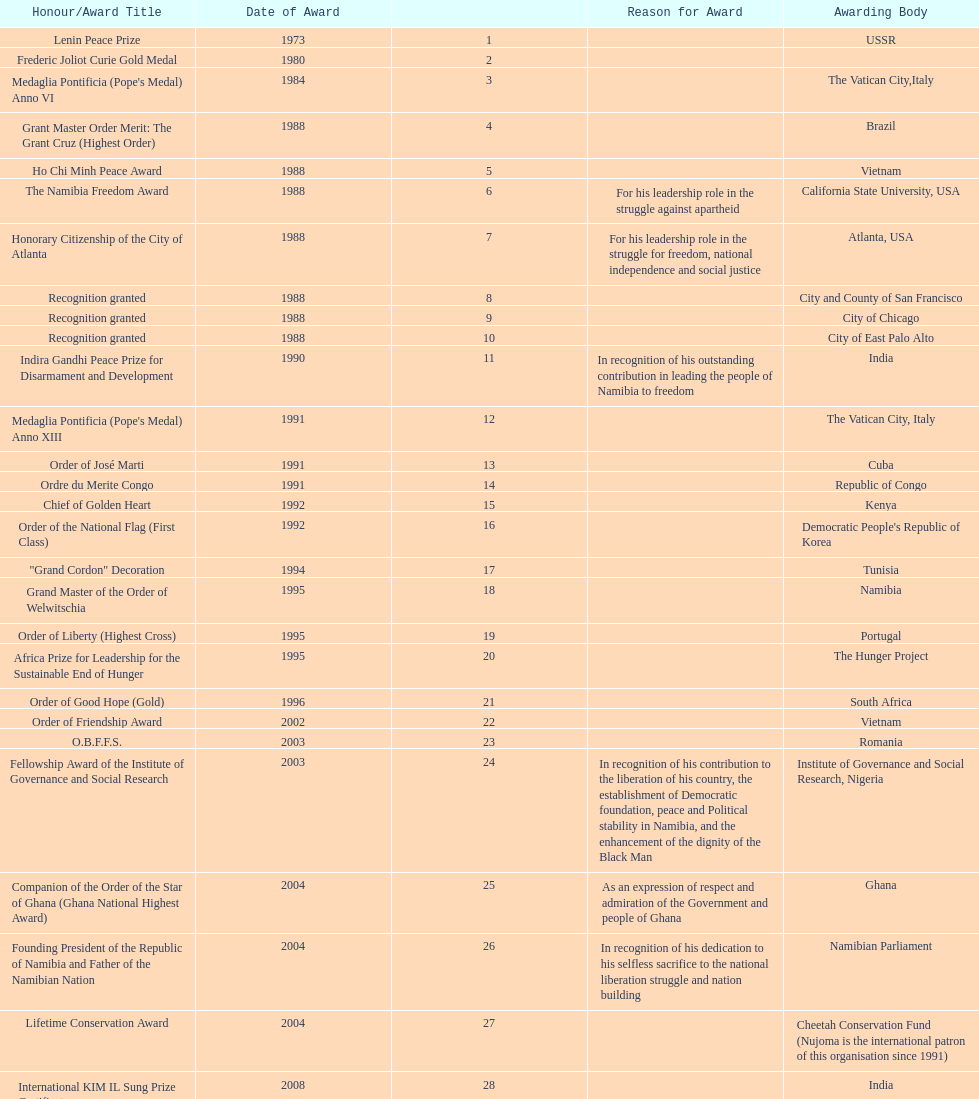What were the total number of honors/award titles listed according to this chart? 29. Help me parse the entirety of this table. {'header': ['Honour/Award Title', 'Date of Award', '', 'Reason for Award', 'Awarding Body'], 'rows': [['Lenin Peace Prize', '1973', '1', '', 'USSR'], ['Frederic Joliot Curie Gold Medal', '1980', '2', '', ''], ["Medaglia Pontificia (Pope's Medal) Anno VI", '1984', '3', '', 'The Vatican City,Italy'], ['Grant Master Order Merit: The Grant Cruz (Highest Order)', '1988', '4', '', 'Brazil'], ['Ho Chi Minh Peace Award', '1988', '5', '', 'Vietnam'], ['The Namibia Freedom Award', '1988', '6', 'For his leadership role in the struggle against apartheid', 'California State University, USA'], ['Honorary Citizenship of the City of Atlanta', '1988', '7', 'For his leadership role in the struggle for freedom, national independence and social justice', 'Atlanta, USA'], ['Recognition granted', '1988', '8', '', 'City and County of San Francisco'], ['Recognition granted', '1988', '9', '', 'City of Chicago'], ['Recognition granted', '1988', '10', '', 'City of East Palo Alto'], ['Indira Gandhi Peace Prize for Disarmament and Development', '1990', '11', 'In recognition of his outstanding contribution in leading the people of Namibia to freedom', 'India'], ["Medaglia Pontificia (Pope's Medal) Anno XIII", '1991', '12', '', 'The Vatican City, Italy'], ['Order of José Marti', '1991', '13', '', 'Cuba'], ['Ordre du Merite Congo', '1991', '14', '', 'Republic of Congo'], ['Chief of Golden Heart', '1992', '15', '', 'Kenya'], ['Order of the National Flag (First Class)', '1992', '16', '', "Democratic People's Republic of Korea"], ['"Grand Cordon" Decoration', '1994', '17', '', 'Tunisia'], ['Grand Master of the Order of Welwitschia', '1995', '18', '', 'Namibia'], ['Order of Liberty (Highest Cross)', '1995', '19', '', 'Portugal'], ['Africa Prize for Leadership for the Sustainable End of Hunger', '1995', '20', '', 'The Hunger Project'], ['Order of Good Hope (Gold)', '1996', '21', '', 'South Africa'], ['Order of Friendship Award', '2002', '22', '', 'Vietnam'], ['O.B.F.F.S.', '2003', '23', '', 'Romania'], ['Fellowship Award of the Institute of Governance and Social Research', '2003', '24', 'In recognition of his contribution to the liberation of his country, the establishment of Democratic foundation, peace and Political stability in Namibia, and the enhancement of the dignity of the Black Man', 'Institute of Governance and Social Research, Nigeria'], ['Companion of the Order of the Star of Ghana (Ghana National Highest Award)', '2004', '25', 'As an expression of respect and admiration of the Government and people of Ghana', 'Ghana'], ['Founding President of the Republic of Namibia and Father of the Namibian Nation', '2004', '26', 'In recognition of his dedication to his selfless sacrifice to the national liberation struggle and nation building', 'Namibian Parliament'], ['Lifetime Conservation Award', '2004', '27', '', 'Cheetah Conservation Fund (Nujoma is the international patron of this organisation since 1991)'], ['International KIM IL Sung Prize Certificate', '2008', '28', '', 'India'], ['Sir Seretse Khama SADC Meda', '2010', '29', '', 'SADC']]} 